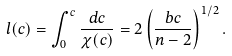<formula> <loc_0><loc_0><loc_500><loc_500>l ( c ) = \int _ { 0 } ^ { c } \frac { d c } { \chi ( c ) } = 2 \left ( \frac { b c } { n - 2 } \right ) ^ { 1 / 2 } .</formula> 